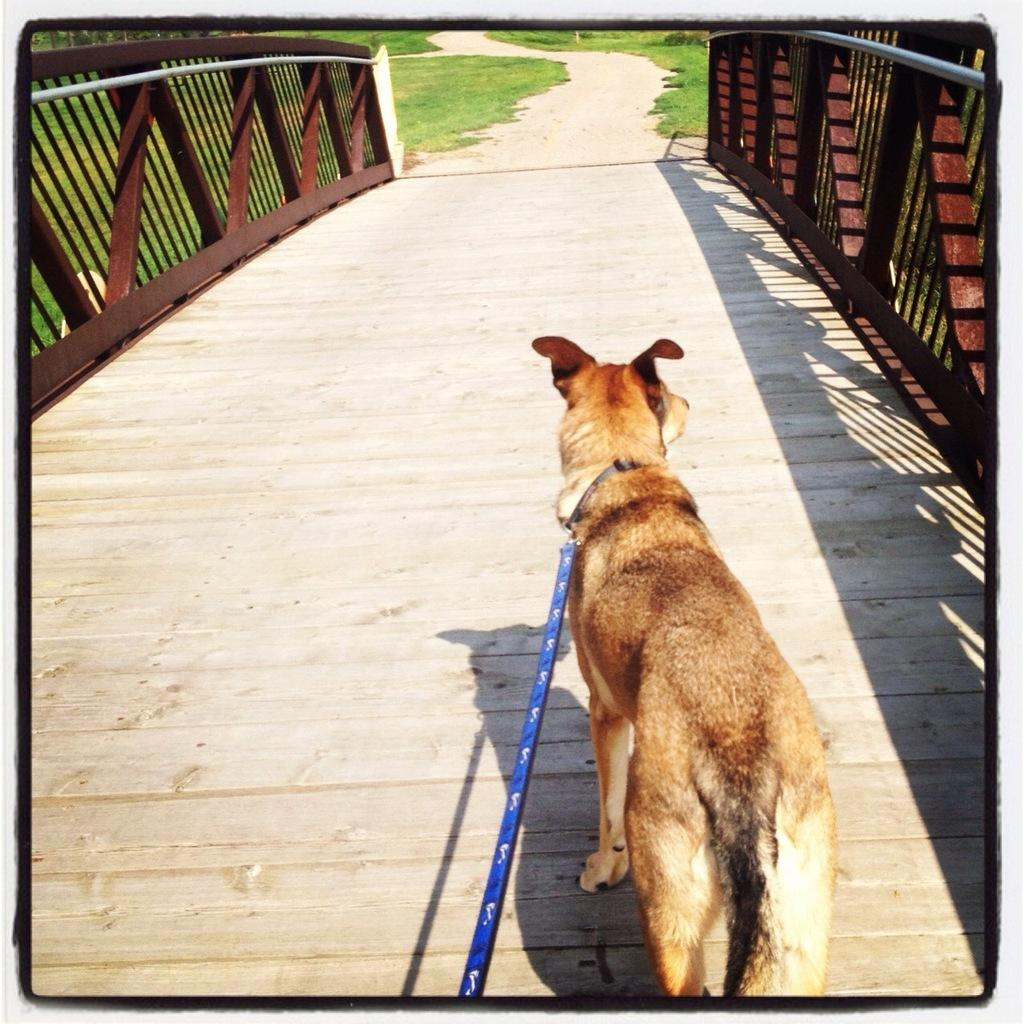What type of animal is in the image? There is a dog in the image. How is the dog being controlled or restrained? The dog has a leash. What is the surface the dog is standing on? The dog is on a wooden surface. What type of structure can be seen in the image? There is railing visible in the image. What is the pathway made of in the image? The pathway in the image is made of grass. What type of butter is being used to grease the door in the image? There is no butter or door present in the image; it features a dog on a wooden surface with railing and a grass pathway. 